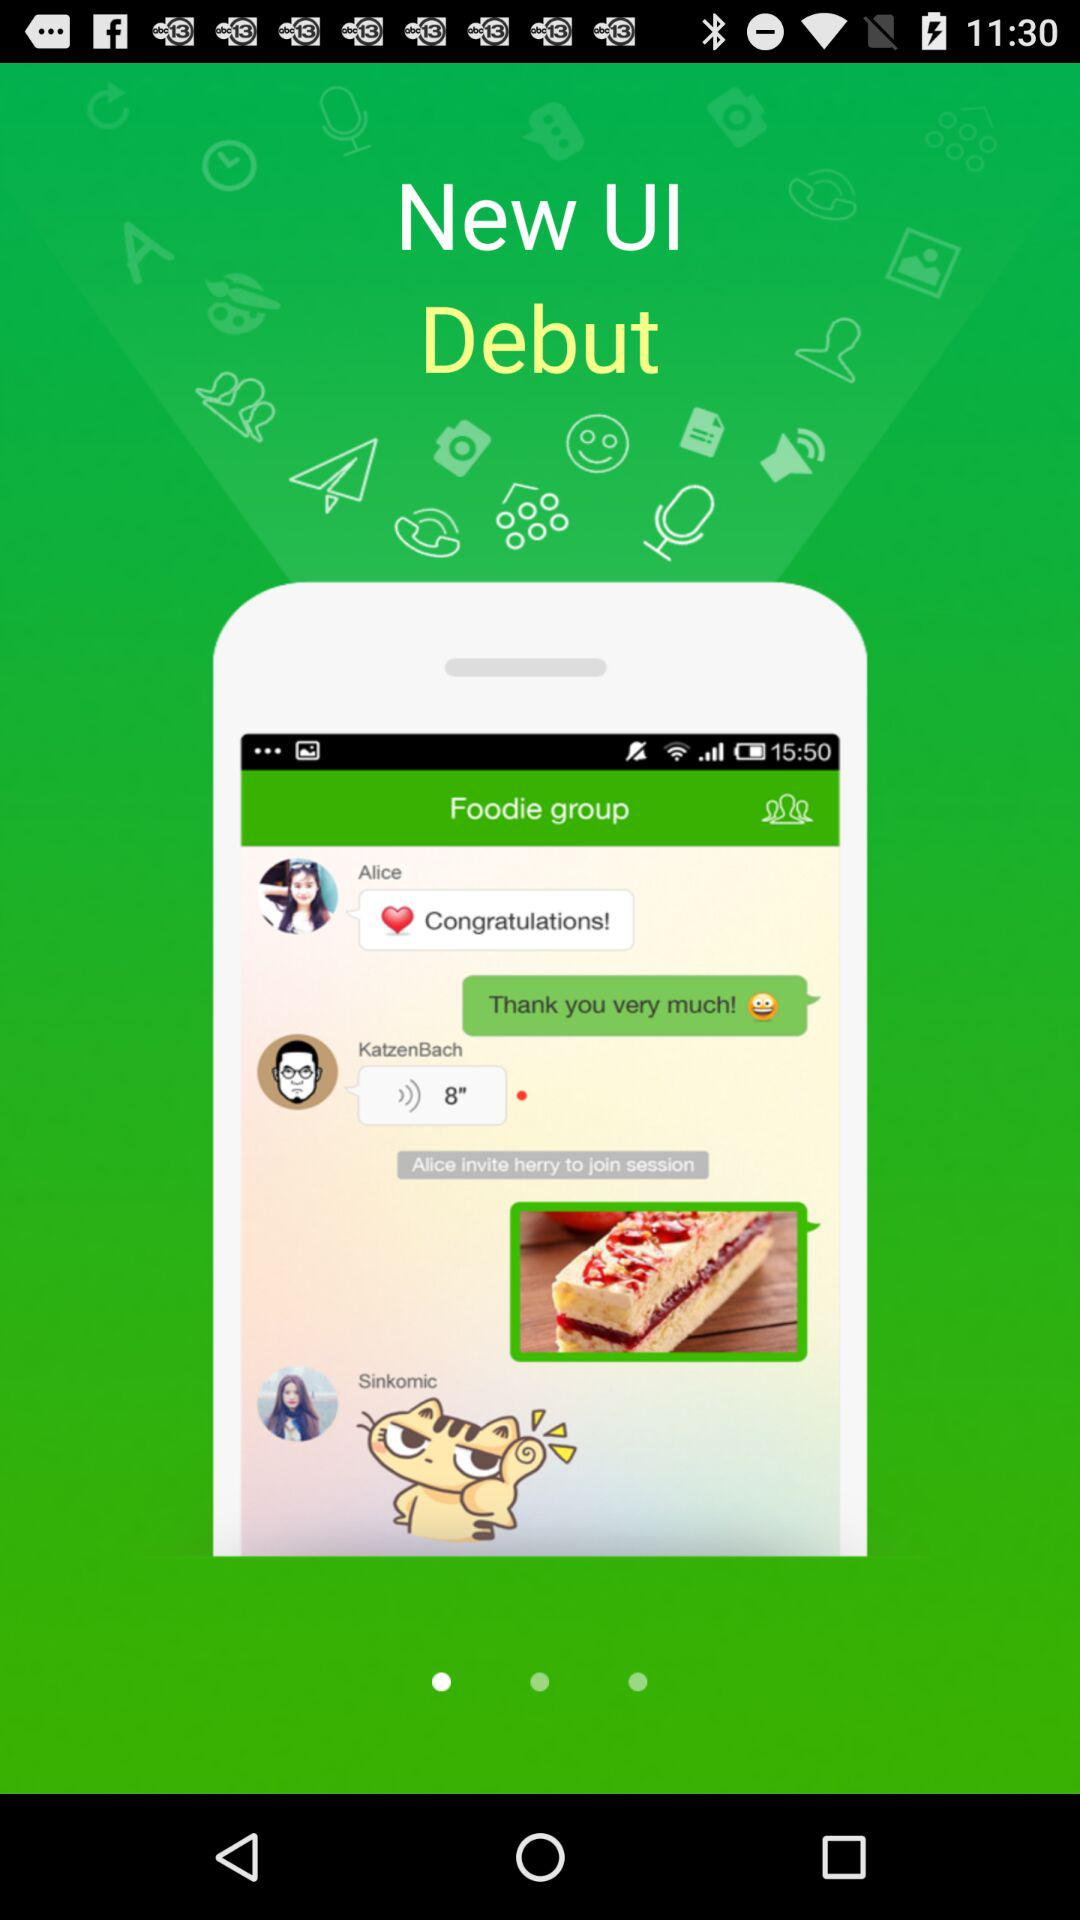What is the name of the application? The name is "New UI". 